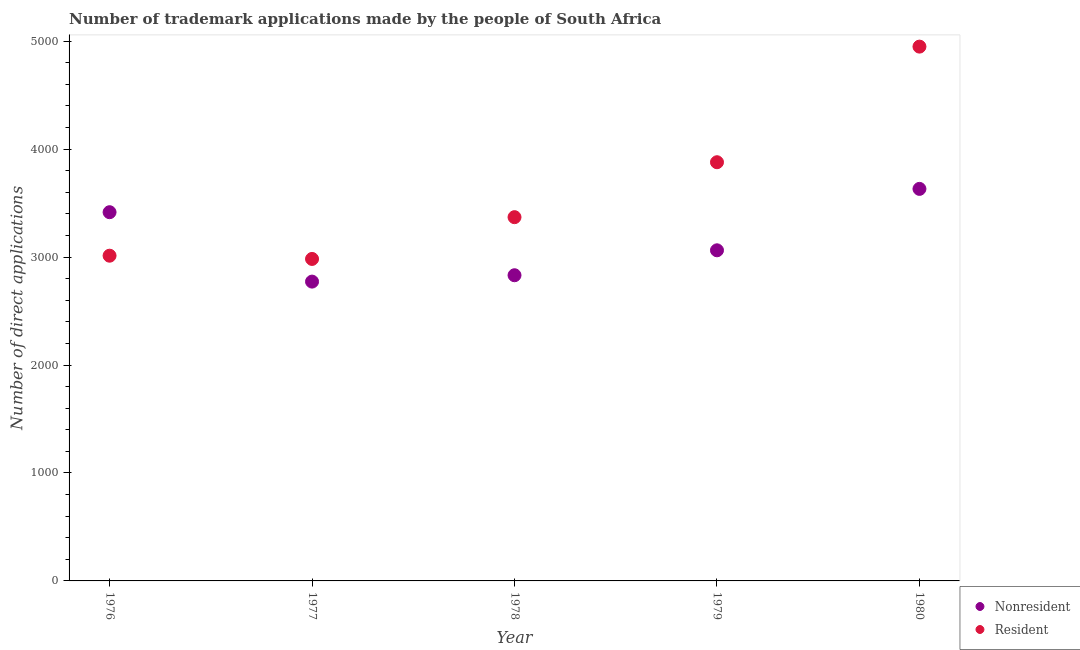How many different coloured dotlines are there?
Provide a short and direct response. 2. What is the number of trademark applications made by non residents in 1979?
Your answer should be compact. 3063. Across all years, what is the maximum number of trademark applications made by non residents?
Keep it short and to the point. 3632. Across all years, what is the minimum number of trademark applications made by non residents?
Keep it short and to the point. 2773. In which year was the number of trademark applications made by residents maximum?
Provide a short and direct response. 1980. In which year was the number of trademark applications made by non residents minimum?
Offer a very short reply. 1977. What is the total number of trademark applications made by non residents in the graph?
Provide a short and direct response. 1.57e+04. What is the difference between the number of trademark applications made by non residents in 1976 and that in 1980?
Give a very brief answer. -216. What is the difference between the number of trademark applications made by non residents in 1979 and the number of trademark applications made by residents in 1978?
Provide a succinct answer. -307. What is the average number of trademark applications made by non residents per year?
Give a very brief answer. 3143.2. In the year 1977, what is the difference between the number of trademark applications made by residents and number of trademark applications made by non residents?
Offer a terse response. 210. What is the ratio of the number of trademark applications made by non residents in 1978 to that in 1979?
Your response must be concise. 0.92. What is the difference between the highest and the second highest number of trademark applications made by non residents?
Keep it short and to the point. 216. What is the difference between the highest and the lowest number of trademark applications made by residents?
Offer a terse response. 1967. Is the sum of the number of trademark applications made by residents in 1976 and 1979 greater than the maximum number of trademark applications made by non residents across all years?
Provide a short and direct response. Yes. Does the number of trademark applications made by residents monotonically increase over the years?
Your answer should be compact. No. Is the number of trademark applications made by residents strictly less than the number of trademark applications made by non residents over the years?
Keep it short and to the point. No. How many dotlines are there?
Your answer should be compact. 2. What is the difference between two consecutive major ticks on the Y-axis?
Give a very brief answer. 1000. Does the graph contain grids?
Your answer should be compact. No. How many legend labels are there?
Ensure brevity in your answer.  2. How are the legend labels stacked?
Your response must be concise. Vertical. What is the title of the graph?
Give a very brief answer. Number of trademark applications made by the people of South Africa. What is the label or title of the X-axis?
Keep it short and to the point. Year. What is the label or title of the Y-axis?
Provide a short and direct response. Number of direct applications. What is the Number of direct applications in Nonresident in 1976?
Ensure brevity in your answer.  3416. What is the Number of direct applications in Resident in 1976?
Your answer should be very brief. 3013. What is the Number of direct applications in Nonresident in 1977?
Your answer should be very brief. 2773. What is the Number of direct applications in Resident in 1977?
Your response must be concise. 2983. What is the Number of direct applications of Nonresident in 1978?
Offer a terse response. 2832. What is the Number of direct applications of Resident in 1978?
Provide a short and direct response. 3370. What is the Number of direct applications in Nonresident in 1979?
Keep it short and to the point. 3063. What is the Number of direct applications of Resident in 1979?
Your answer should be compact. 3879. What is the Number of direct applications in Nonresident in 1980?
Keep it short and to the point. 3632. What is the Number of direct applications in Resident in 1980?
Keep it short and to the point. 4950. Across all years, what is the maximum Number of direct applications in Nonresident?
Ensure brevity in your answer.  3632. Across all years, what is the maximum Number of direct applications in Resident?
Your response must be concise. 4950. Across all years, what is the minimum Number of direct applications in Nonresident?
Offer a very short reply. 2773. Across all years, what is the minimum Number of direct applications of Resident?
Keep it short and to the point. 2983. What is the total Number of direct applications in Nonresident in the graph?
Provide a short and direct response. 1.57e+04. What is the total Number of direct applications of Resident in the graph?
Offer a very short reply. 1.82e+04. What is the difference between the Number of direct applications in Nonresident in 1976 and that in 1977?
Offer a terse response. 643. What is the difference between the Number of direct applications in Resident in 1976 and that in 1977?
Provide a succinct answer. 30. What is the difference between the Number of direct applications in Nonresident in 1976 and that in 1978?
Your response must be concise. 584. What is the difference between the Number of direct applications in Resident in 1976 and that in 1978?
Your answer should be compact. -357. What is the difference between the Number of direct applications of Nonresident in 1976 and that in 1979?
Ensure brevity in your answer.  353. What is the difference between the Number of direct applications in Resident in 1976 and that in 1979?
Your response must be concise. -866. What is the difference between the Number of direct applications of Nonresident in 1976 and that in 1980?
Provide a short and direct response. -216. What is the difference between the Number of direct applications in Resident in 1976 and that in 1980?
Offer a very short reply. -1937. What is the difference between the Number of direct applications of Nonresident in 1977 and that in 1978?
Your answer should be very brief. -59. What is the difference between the Number of direct applications of Resident in 1977 and that in 1978?
Keep it short and to the point. -387. What is the difference between the Number of direct applications in Nonresident in 1977 and that in 1979?
Your answer should be very brief. -290. What is the difference between the Number of direct applications in Resident in 1977 and that in 1979?
Your answer should be very brief. -896. What is the difference between the Number of direct applications of Nonresident in 1977 and that in 1980?
Your response must be concise. -859. What is the difference between the Number of direct applications in Resident in 1977 and that in 1980?
Make the answer very short. -1967. What is the difference between the Number of direct applications of Nonresident in 1978 and that in 1979?
Provide a short and direct response. -231. What is the difference between the Number of direct applications in Resident in 1978 and that in 1979?
Keep it short and to the point. -509. What is the difference between the Number of direct applications of Nonresident in 1978 and that in 1980?
Your answer should be very brief. -800. What is the difference between the Number of direct applications in Resident in 1978 and that in 1980?
Your answer should be very brief. -1580. What is the difference between the Number of direct applications of Nonresident in 1979 and that in 1980?
Give a very brief answer. -569. What is the difference between the Number of direct applications of Resident in 1979 and that in 1980?
Your response must be concise. -1071. What is the difference between the Number of direct applications of Nonresident in 1976 and the Number of direct applications of Resident in 1977?
Offer a very short reply. 433. What is the difference between the Number of direct applications in Nonresident in 1976 and the Number of direct applications in Resident in 1978?
Your answer should be very brief. 46. What is the difference between the Number of direct applications of Nonresident in 1976 and the Number of direct applications of Resident in 1979?
Your answer should be very brief. -463. What is the difference between the Number of direct applications in Nonresident in 1976 and the Number of direct applications in Resident in 1980?
Your answer should be compact. -1534. What is the difference between the Number of direct applications of Nonresident in 1977 and the Number of direct applications of Resident in 1978?
Provide a short and direct response. -597. What is the difference between the Number of direct applications of Nonresident in 1977 and the Number of direct applications of Resident in 1979?
Provide a short and direct response. -1106. What is the difference between the Number of direct applications in Nonresident in 1977 and the Number of direct applications in Resident in 1980?
Keep it short and to the point. -2177. What is the difference between the Number of direct applications in Nonresident in 1978 and the Number of direct applications in Resident in 1979?
Your response must be concise. -1047. What is the difference between the Number of direct applications of Nonresident in 1978 and the Number of direct applications of Resident in 1980?
Your answer should be compact. -2118. What is the difference between the Number of direct applications in Nonresident in 1979 and the Number of direct applications in Resident in 1980?
Offer a terse response. -1887. What is the average Number of direct applications of Nonresident per year?
Offer a very short reply. 3143.2. What is the average Number of direct applications of Resident per year?
Provide a succinct answer. 3639. In the year 1976, what is the difference between the Number of direct applications of Nonresident and Number of direct applications of Resident?
Offer a terse response. 403. In the year 1977, what is the difference between the Number of direct applications in Nonresident and Number of direct applications in Resident?
Your response must be concise. -210. In the year 1978, what is the difference between the Number of direct applications of Nonresident and Number of direct applications of Resident?
Your response must be concise. -538. In the year 1979, what is the difference between the Number of direct applications in Nonresident and Number of direct applications in Resident?
Your answer should be compact. -816. In the year 1980, what is the difference between the Number of direct applications of Nonresident and Number of direct applications of Resident?
Ensure brevity in your answer.  -1318. What is the ratio of the Number of direct applications in Nonresident in 1976 to that in 1977?
Ensure brevity in your answer.  1.23. What is the ratio of the Number of direct applications of Resident in 1976 to that in 1977?
Your answer should be compact. 1.01. What is the ratio of the Number of direct applications in Nonresident in 1976 to that in 1978?
Offer a very short reply. 1.21. What is the ratio of the Number of direct applications in Resident in 1976 to that in 1978?
Keep it short and to the point. 0.89. What is the ratio of the Number of direct applications of Nonresident in 1976 to that in 1979?
Provide a succinct answer. 1.12. What is the ratio of the Number of direct applications of Resident in 1976 to that in 1979?
Your answer should be very brief. 0.78. What is the ratio of the Number of direct applications in Nonresident in 1976 to that in 1980?
Your answer should be compact. 0.94. What is the ratio of the Number of direct applications of Resident in 1976 to that in 1980?
Keep it short and to the point. 0.61. What is the ratio of the Number of direct applications in Nonresident in 1977 to that in 1978?
Offer a very short reply. 0.98. What is the ratio of the Number of direct applications of Resident in 1977 to that in 1978?
Your answer should be very brief. 0.89. What is the ratio of the Number of direct applications in Nonresident in 1977 to that in 1979?
Keep it short and to the point. 0.91. What is the ratio of the Number of direct applications of Resident in 1977 to that in 1979?
Make the answer very short. 0.77. What is the ratio of the Number of direct applications of Nonresident in 1977 to that in 1980?
Your answer should be very brief. 0.76. What is the ratio of the Number of direct applications of Resident in 1977 to that in 1980?
Ensure brevity in your answer.  0.6. What is the ratio of the Number of direct applications in Nonresident in 1978 to that in 1979?
Your response must be concise. 0.92. What is the ratio of the Number of direct applications in Resident in 1978 to that in 1979?
Give a very brief answer. 0.87. What is the ratio of the Number of direct applications in Nonresident in 1978 to that in 1980?
Your answer should be compact. 0.78. What is the ratio of the Number of direct applications in Resident in 1978 to that in 1980?
Your answer should be compact. 0.68. What is the ratio of the Number of direct applications in Nonresident in 1979 to that in 1980?
Give a very brief answer. 0.84. What is the ratio of the Number of direct applications in Resident in 1979 to that in 1980?
Offer a very short reply. 0.78. What is the difference between the highest and the second highest Number of direct applications in Nonresident?
Keep it short and to the point. 216. What is the difference between the highest and the second highest Number of direct applications of Resident?
Give a very brief answer. 1071. What is the difference between the highest and the lowest Number of direct applications in Nonresident?
Make the answer very short. 859. What is the difference between the highest and the lowest Number of direct applications in Resident?
Give a very brief answer. 1967. 